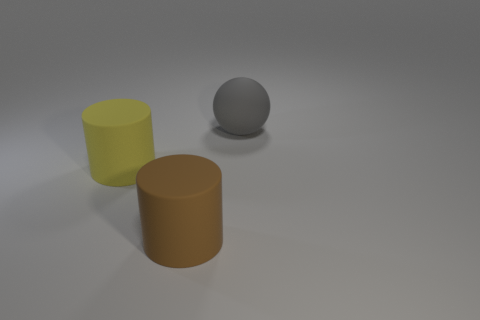Is there any other thing that is the same shape as the gray matte thing?
Your response must be concise. No. There is a brown rubber object; what shape is it?
Offer a very short reply. Cylinder. Is the number of big yellow matte cylinders that are in front of the brown cylinder greater than the number of large cylinders on the right side of the large yellow matte thing?
Your response must be concise. No. Do the big object that is left of the brown rubber thing and the thing to the right of the brown matte object have the same shape?
Your answer should be compact. No. What size is the matte sphere?
Provide a succinct answer. Large. Is the big thing that is right of the brown matte thing made of the same material as the large brown object?
Offer a terse response. Yes. There is another big rubber thing that is the same shape as the large brown rubber object; what color is it?
Your answer should be very brief. Yellow. Does the big cylinder to the left of the brown object have the same color as the ball?
Make the answer very short. No. Are there any gray spheres in front of the large yellow thing?
Provide a short and direct response. No. What is the color of the object that is left of the gray matte ball and behind the brown rubber cylinder?
Give a very brief answer. Yellow. 